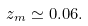<formula> <loc_0><loc_0><loc_500><loc_500>z _ { m } \simeq 0 . 0 6 .</formula> 